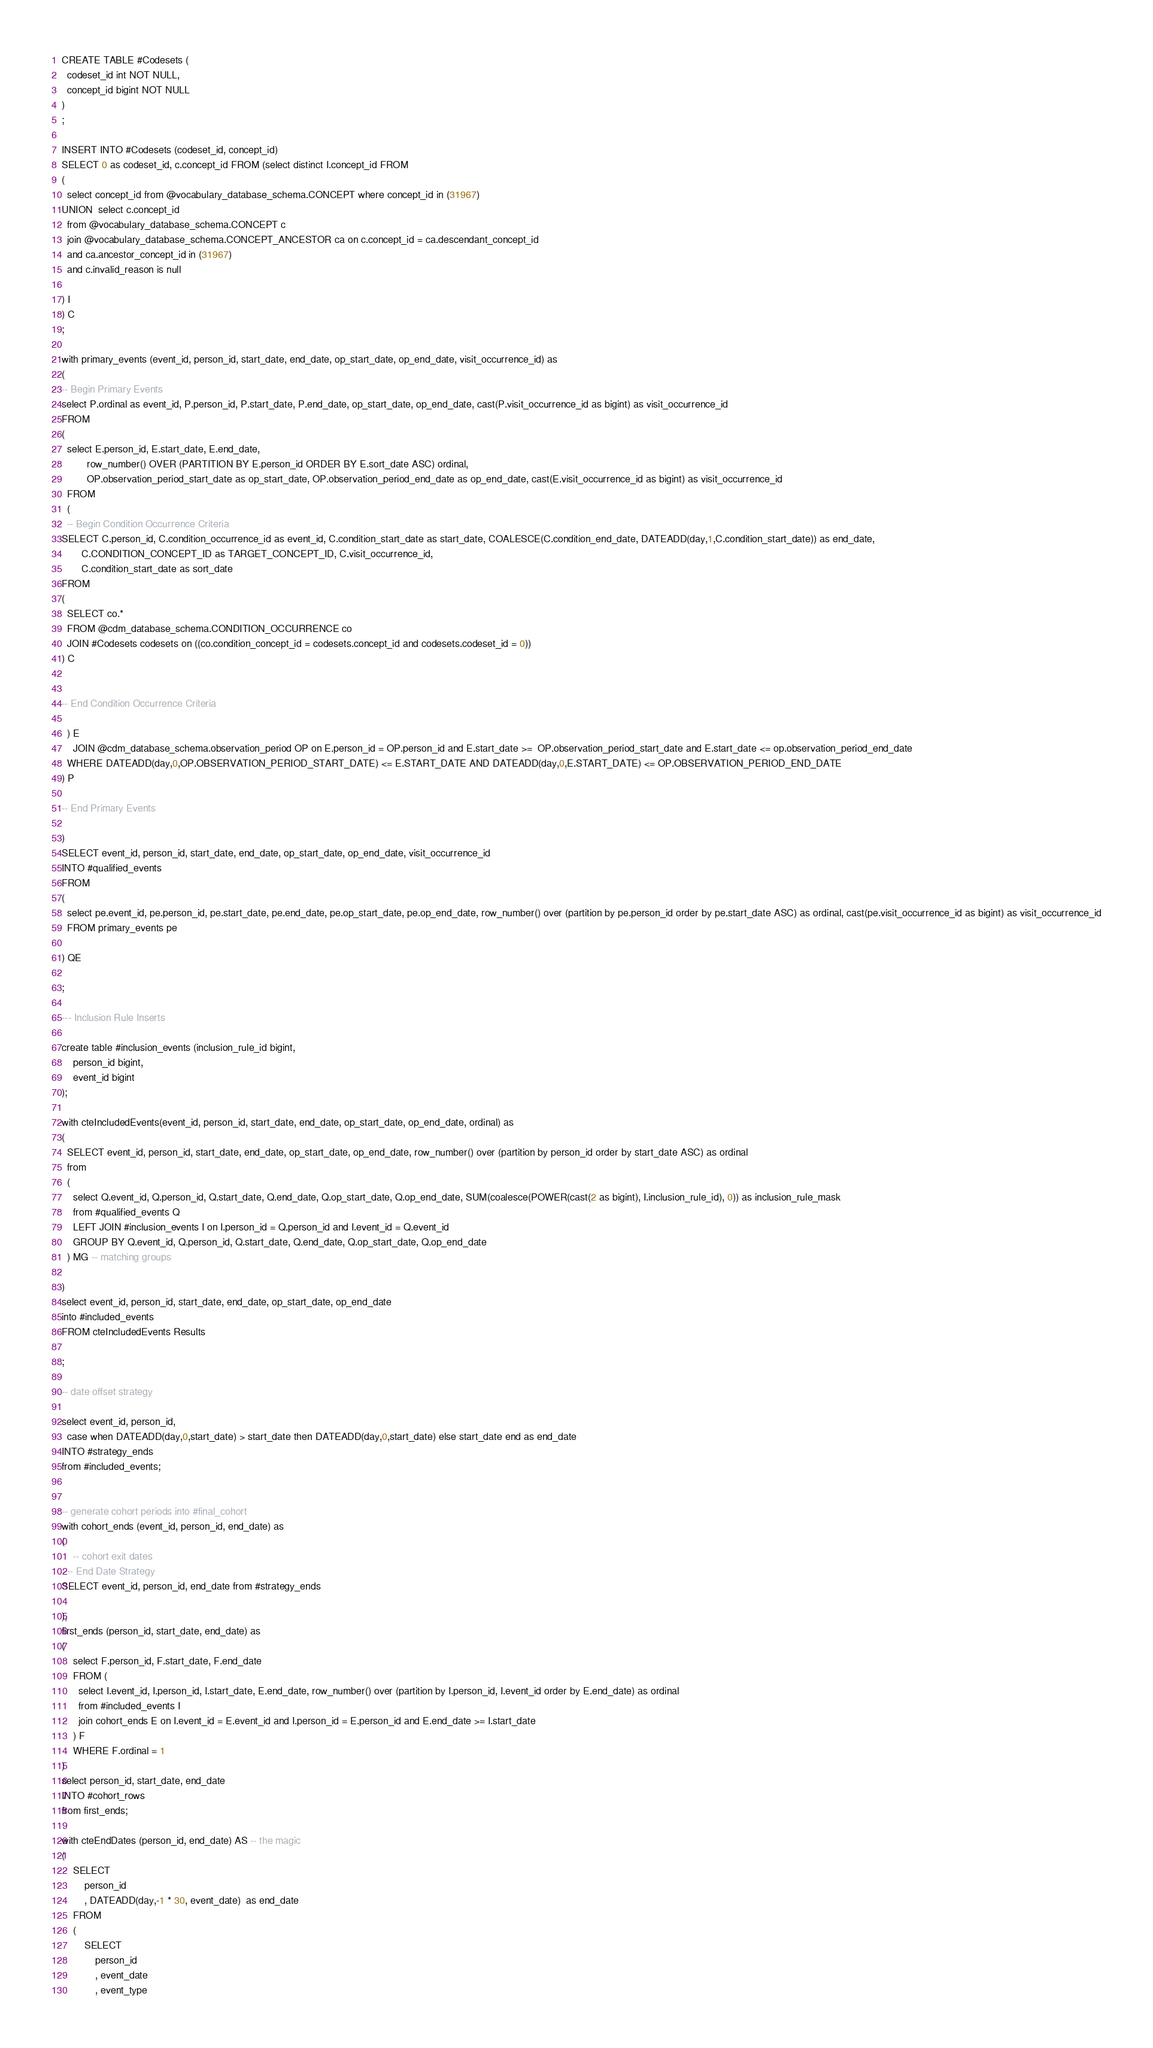<code> <loc_0><loc_0><loc_500><loc_500><_SQL_>CREATE TABLE #Codesets (
  codeset_id int NOT NULL,
  concept_id bigint NOT NULL
)
;

INSERT INTO #Codesets (codeset_id, concept_id)
SELECT 0 as codeset_id, c.concept_id FROM (select distinct I.concept_id FROM
( 
  select concept_id from @vocabulary_database_schema.CONCEPT where concept_id in (31967)
UNION  select c.concept_id
  from @vocabulary_database_schema.CONCEPT c
  join @vocabulary_database_schema.CONCEPT_ANCESTOR ca on c.concept_id = ca.descendant_concept_id
  and ca.ancestor_concept_id in (31967)
  and c.invalid_reason is null

) I
) C
;

with primary_events (event_id, person_id, start_date, end_date, op_start_date, op_end_date, visit_occurrence_id) as
(
-- Begin Primary Events
select P.ordinal as event_id, P.person_id, P.start_date, P.end_date, op_start_date, op_end_date, cast(P.visit_occurrence_id as bigint) as visit_occurrence_id
FROM
(
  select E.person_id, E.start_date, E.end_date,
         row_number() OVER (PARTITION BY E.person_id ORDER BY E.sort_date ASC) ordinal,
         OP.observation_period_start_date as op_start_date, OP.observation_period_end_date as op_end_date, cast(E.visit_occurrence_id as bigint) as visit_occurrence_id
  FROM 
  (
  -- Begin Condition Occurrence Criteria
SELECT C.person_id, C.condition_occurrence_id as event_id, C.condition_start_date as start_date, COALESCE(C.condition_end_date, DATEADD(day,1,C.condition_start_date)) as end_date,
       C.CONDITION_CONCEPT_ID as TARGET_CONCEPT_ID, C.visit_occurrence_id,
       C.condition_start_date as sort_date
FROM 
(
  SELECT co.* 
  FROM @cdm_database_schema.CONDITION_OCCURRENCE co
  JOIN #Codesets codesets on ((co.condition_concept_id = codesets.concept_id and codesets.codeset_id = 0))
) C


-- End Condition Occurrence Criteria

  ) E
	JOIN @cdm_database_schema.observation_period OP on E.person_id = OP.person_id and E.start_date >=  OP.observation_period_start_date and E.start_date <= op.observation_period_end_date
  WHERE DATEADD(day,0,OP.OBSERVATION_PERIOD_START_DATE) <= E.START_DATE AND DATEADD(day,0,E.START_DATE) <= OP.OBSERVATION_PERIOD_END_DATE
) P

-- End Primary Events

)
SELECT event_id, person_id, start_date, end_date, op_start_date, op_end_date, visit_occurrence_id
INTO #qualified_events
FROM 
(
  select pe.event_id, pe.person_id, pe.start_date, pe.end_date, pe.op_start_date, pe.op_end_date, row_number() over (partition by pe.person_id order by pe.start_date ASC) as ordinal, cast(pe.visit_occurrence_id as bigint) as visit_occurrence_id
  FROM primary_events pe
  
) QE

;

--- Inclusion Rule Inserts

create table #inclusion_events (inclusion_rule_id bigint,
	person_id bigint,
	event_id bigint
);

with cteIncludedEvents(event_id, person_id, start_date, end_date, op_start_date, op_end_date, ordinal) as
(
  SELECT event_id, person_id, start_date, end_date, op_start_date, op_end_date, row_number() over (partition by person_id order by start_date ASC) as ordinal
  from
  (
    select Q.event_id, Q.person_id, Q.start_date, Q.end_date, Q.op_start_date, Q.op_end_date, SUM(coalesce(POWER(cast(2 as bigint), I.inclusion_rule_id), 0)) as inclusion_rule_mask
    from #qualified_events Q
    LEFT JOIN #inclusion_events I on I.person_id = Q.person_id and I.event_id = Q.event_id
    GROUP BY Q.event_id, Q.person_id, Q.start_date, Q.end_date, Q.op_start_date, Q.op_end_date
  ) MG -- matching groups

)
select event_id, person_id, start_date, end_date, op_start_date, op_end_date
into #included_events
FROM cteIncludedEvents Results

;

-- date offset strategy

select event_id, person_id, 
  case when DATEADD(day,0,start_date) > start_date then DATEADD(day,0,start_date) else start_date end as end_date
INTO #strategy_ends
from #included_events;


-- generate cohort periods into #final_cohort
with cohort_ends (event_id, person_id, end_date) as
(
	-- cohort exit dates
  -- End Date Strategy
SELECT event_id, person_id, end_date from #strategy_ends

),
first_ends (person_id, start_date, end_date) as
(
	select F.person_id, F.start_date, F.end_date
	FROM (
	  select I.event_id, I.person_id, I.start_date, E.end_date, row_number() over (partition by I.person_id, I.event_id order by E.end_date) as ordinal 
	  from #included_events I
	  join cohort_ends E on I.event_id = E.event_id and I.person_id = E.person_id and E.end_date >= I.start_date
	) F
	WHERE F.ordinal = 1
)
select person_id, start_date, end_date
INTO #cohort_rows
from first_ends;

with cteEndDates (person_id, end_date) AS -- the magic
(	
	SELECT
		person_id
		, DATEADD(day,-1 * 30, event_date)  as end_date
	FROM
	(
		SELECT
			person_id
			, event_date
			, event_type</code> 